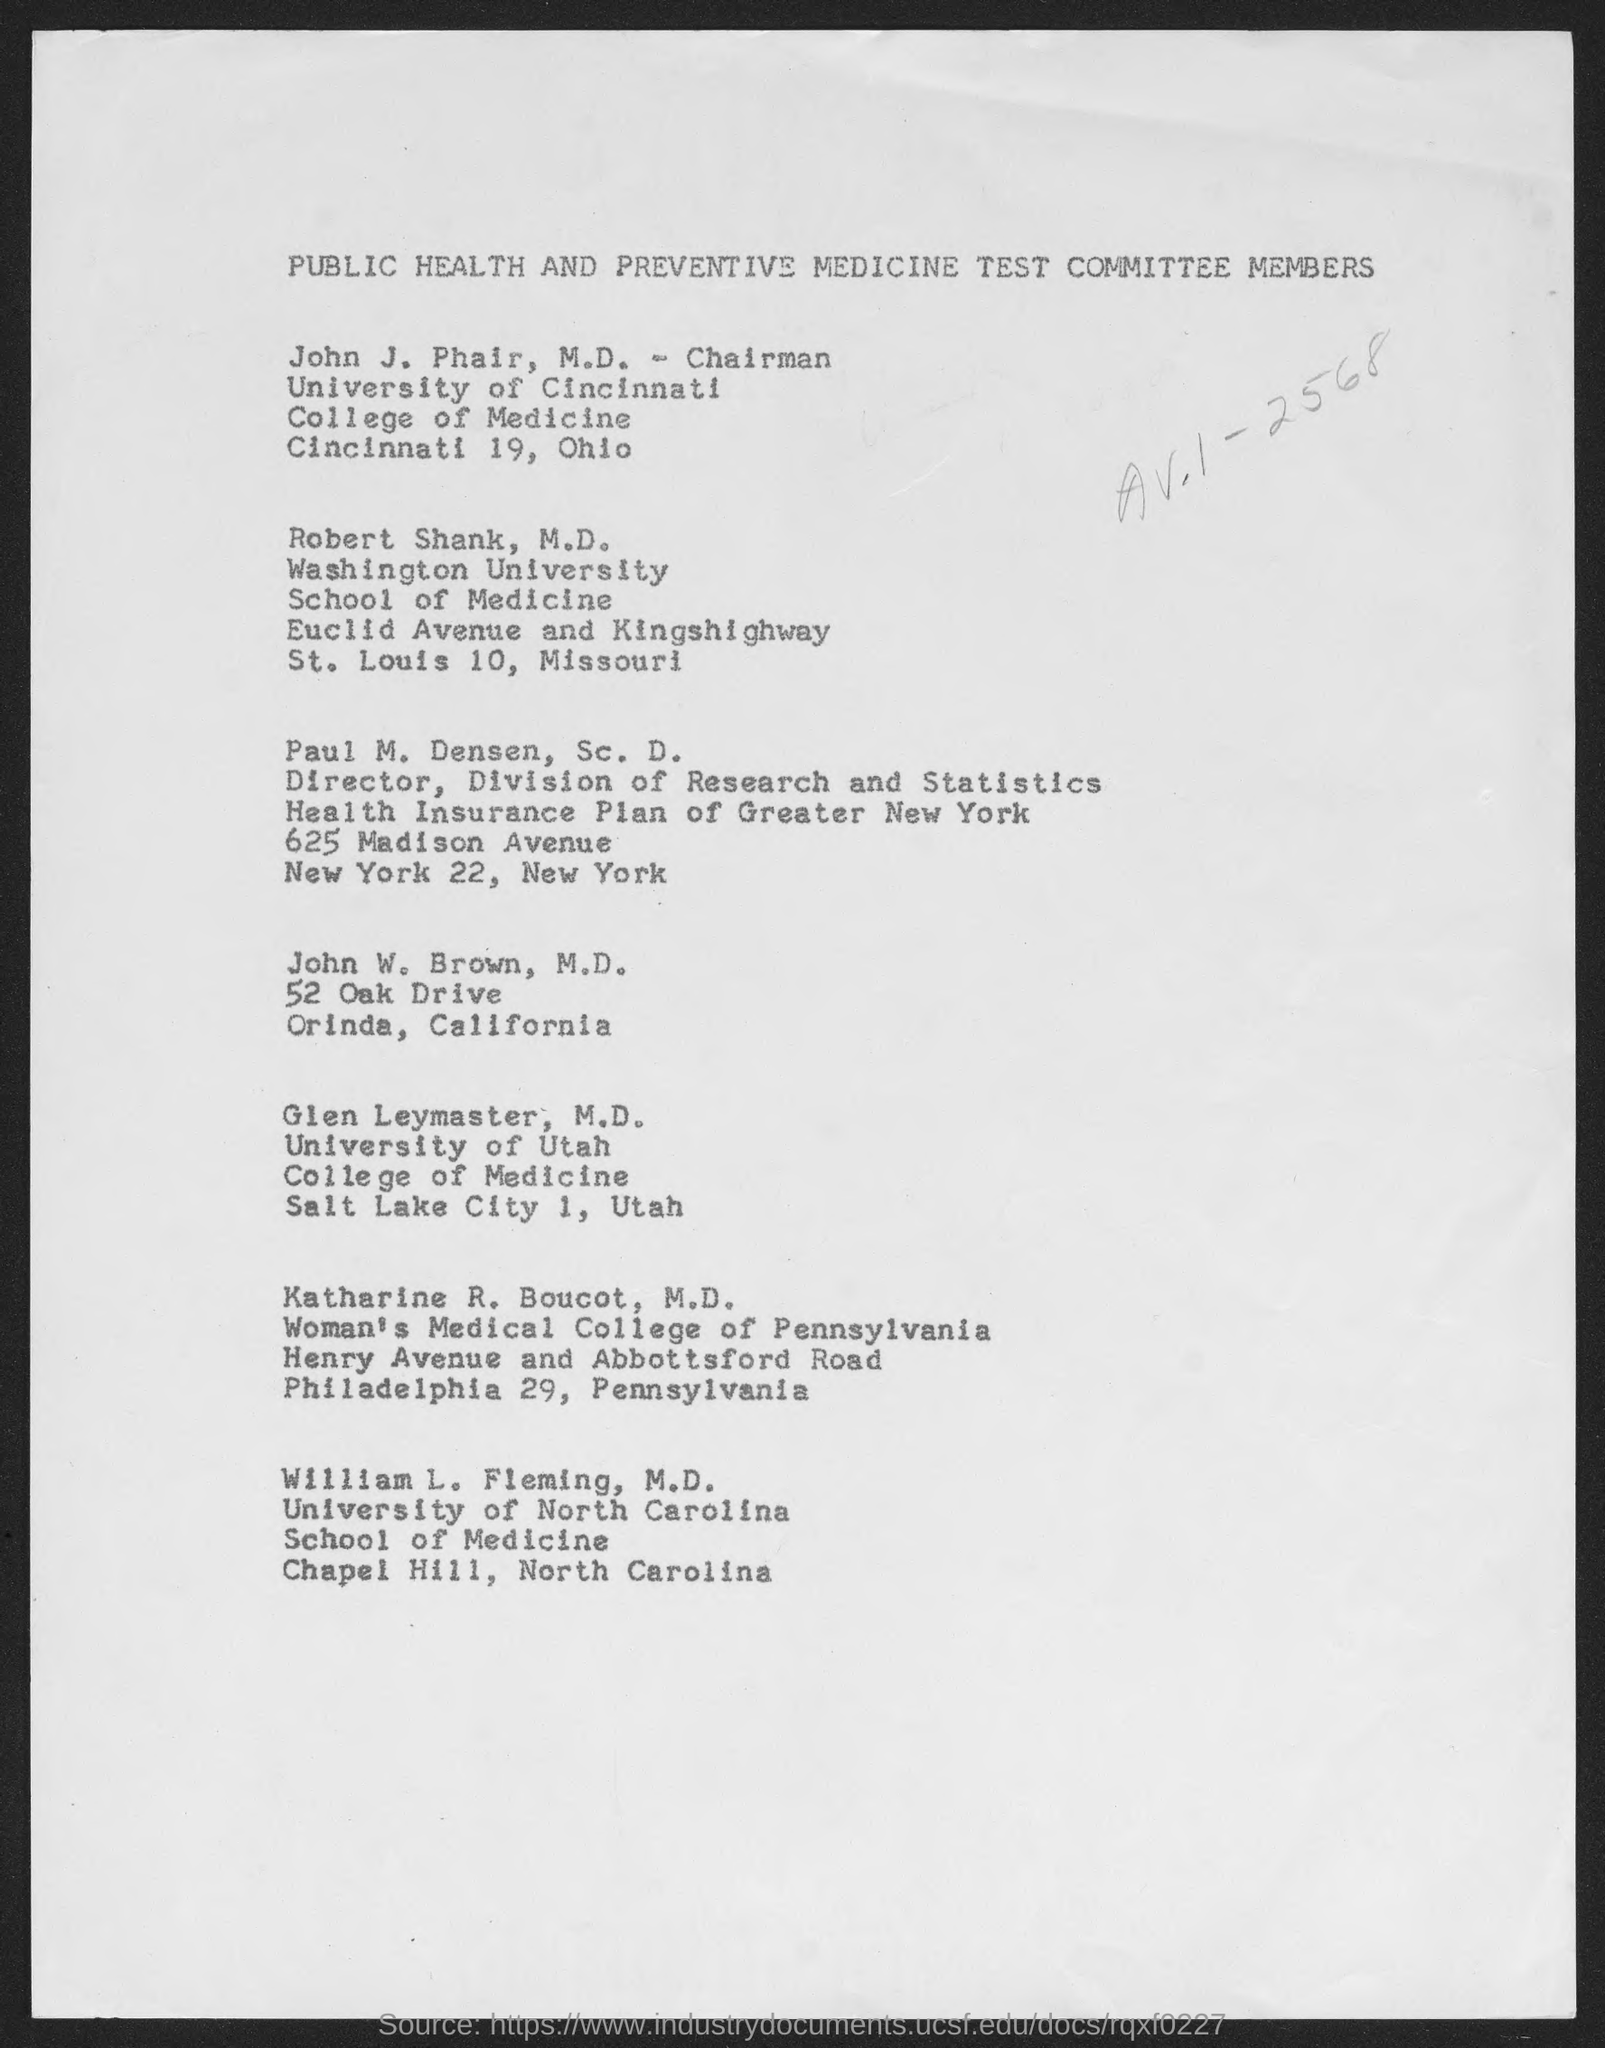In which university, Robert Shank, M.D. works?
Your answer should be compact. Washington University. What is the designation of Paul M. Densen, Sc. D.?
Make the answer very short. Director. 